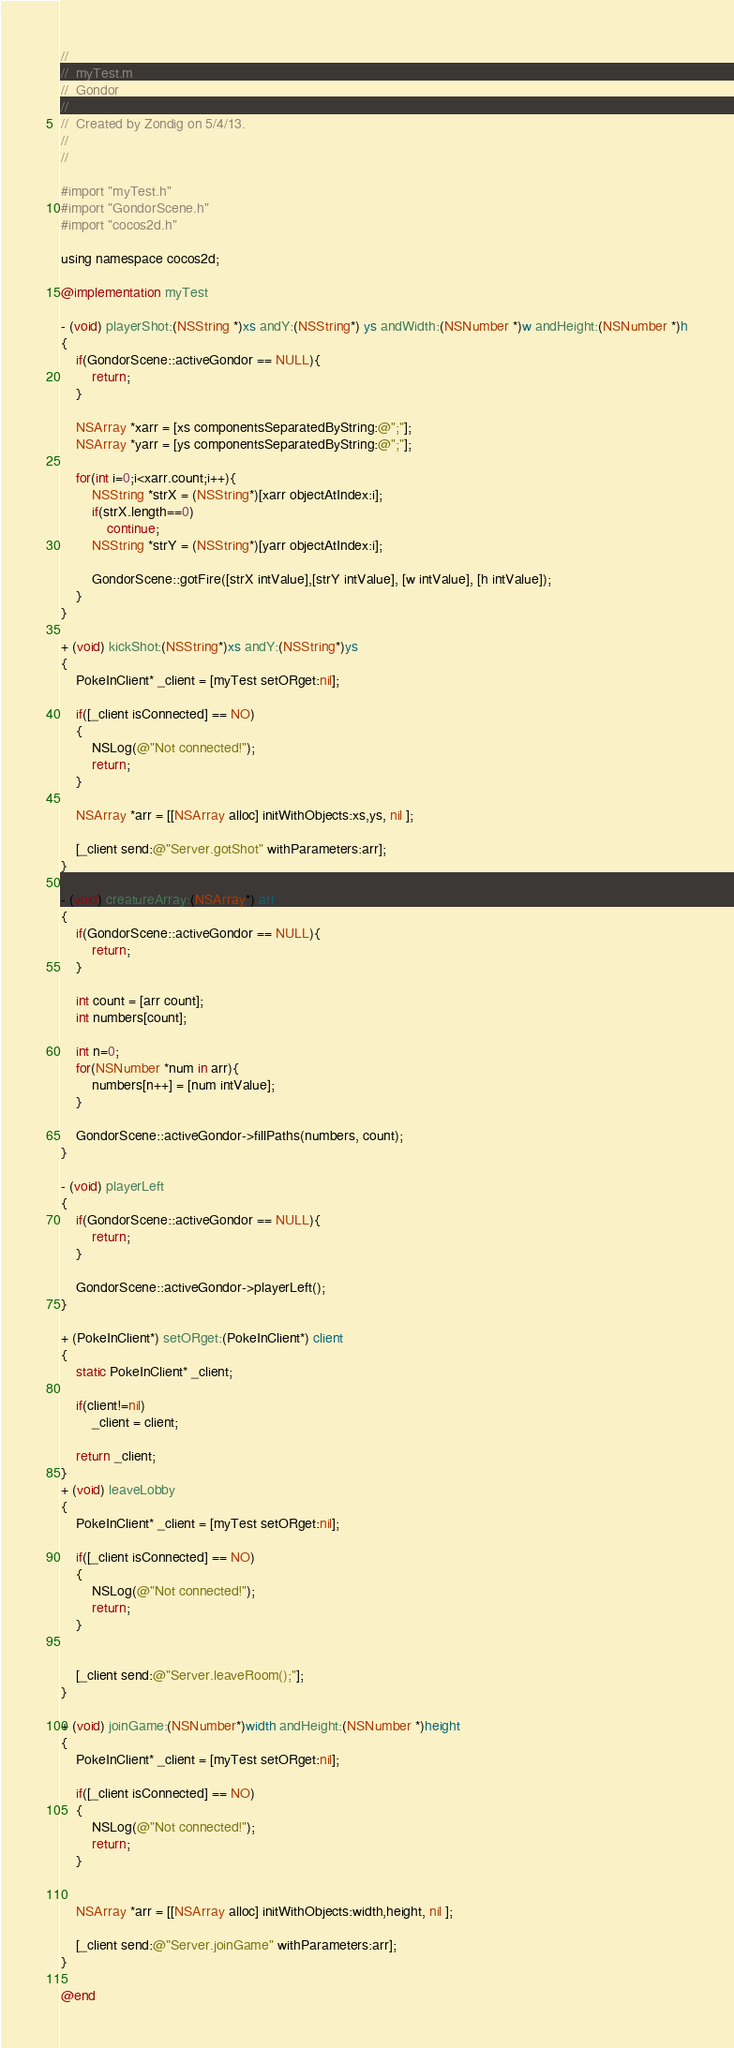Convert code to text. <code><loc_0><loc_0><loc_500><loc_500><_ObjectiveC_>//
//  myTest.m
//  Gondor
//
//  Created by Zondig on 5/4/13.
//
//

#import "myTest.h"
#import "GondorScene.h"
#import "cocos2d.h"

using namespace cocos2d;

@implementation myTest

- (void) playerShot:(NSString *)xs andY:(NSString*) ys andWidth:(NSNumber *)w andHeight:(NSNumber *)h
{
    if(GondorScene::activeGondor == NULL){
        return;
    }
    
    NSArray *xarr = [xs componentsSeparatedByString:@";"];
    NSArray *yarr = [ys componentsSeparatedByString:@";"];

    for(int i=0;i<xarr.count;i++){
        NSString *strX = (NSString*)[xarr objectAtIndex:i];
        if(strX.length==0)
            continue;
        NSString *strY = (NSString*)[yarr objectAtIndex:i];
        
        GondorScene::gotFire([strX intValue],[strY intValue], [w intValue], [h intValue]);
    }
}

+ (void) kickShot:(NSString*)xs andY:(NSString*)ys
{
    PokeInClient* _client = [myTest setORget:nil];
    
    if([_client isConnected] == NO)
    {
        NSLog(@"Not connected!");
        return;
    }
 
    NSArray *arr = [[NSArray alloc] initWithObjects:xs,ys, nil ];

    [_client send:@"Server.gotShot" withParameters:arr];
}

- (void) creatureArray:(NSArray*) arr
{
    if(GondorScene::activeGondor == NULL){
        return;
    }
    
    int count = [arr count];
    int numbers[count];
    
    int n=0;
    for(NSNumber *num in arr){
        numbers[n++] = [num intValue];
    }
    
    GondorScene::activeGondor->fillPaths(numbers, count);
}

- (void) playerLeft
{
    if(GondorScene::activeGondor == NULL){
        return;
    }
    
    GondorScene::activeGondor->playerLeft();
}

+ (PokeInClient*) setORget:(PokeInClient*) client
{
    static PokeInClient* _client;
    
    if(client!=nil)
        _client = client;
    
    return _client;
}
+ (void) leaveLobby
{
    PokeInClient* _client = [myTest setORget:nil];
    
    if([_client isConnected] == NO)
    {
        NSLog(@"Not connected!");
        return;
    }
    
    
    [_client send:@"Server.leaveRoom();"];
}

+ (void) joinGame:(NSNumber*)width andHeight:(NSNumber *)height
{
    PokeInClient* _client = [myTest setORget:nil];
    
    if([_client isConnected] == NO)
    {
        NSLog(@"Not connected!");
        return;
    }
    
    
    NSArray *arr = [[NSArray alloc] initWithObjects:width,height, nil ];

    [_client send:@"Server.joinGame" withParameters:arr];
}

@end
</code> 